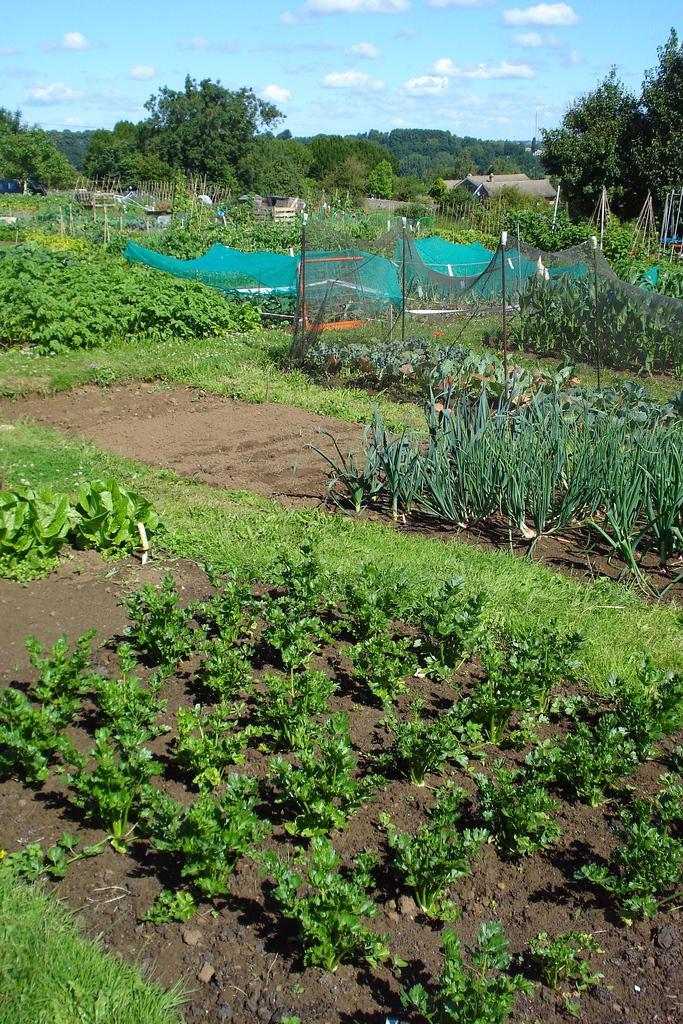Please provide a concise description of this image. In this picture we can see plants on the ground, fencing net, cloth, poles, houses, trees, some objects and in the background we can see the sky with clouds. 